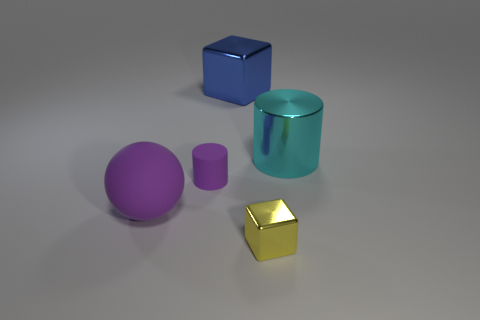Add 4 metal cubes. How many objects exist? 9 Subtract all cubes. How many objects are left? 3 Subtract 0 gray cylinders. How many objects are left? 5 Subtract all matte things. Subtract all large spheres. How many objects are left? 2 Add 5 cyan things. How many cyan things are left? 6 Add 2 small gray blocks. How many small gray blocks exist? 2 